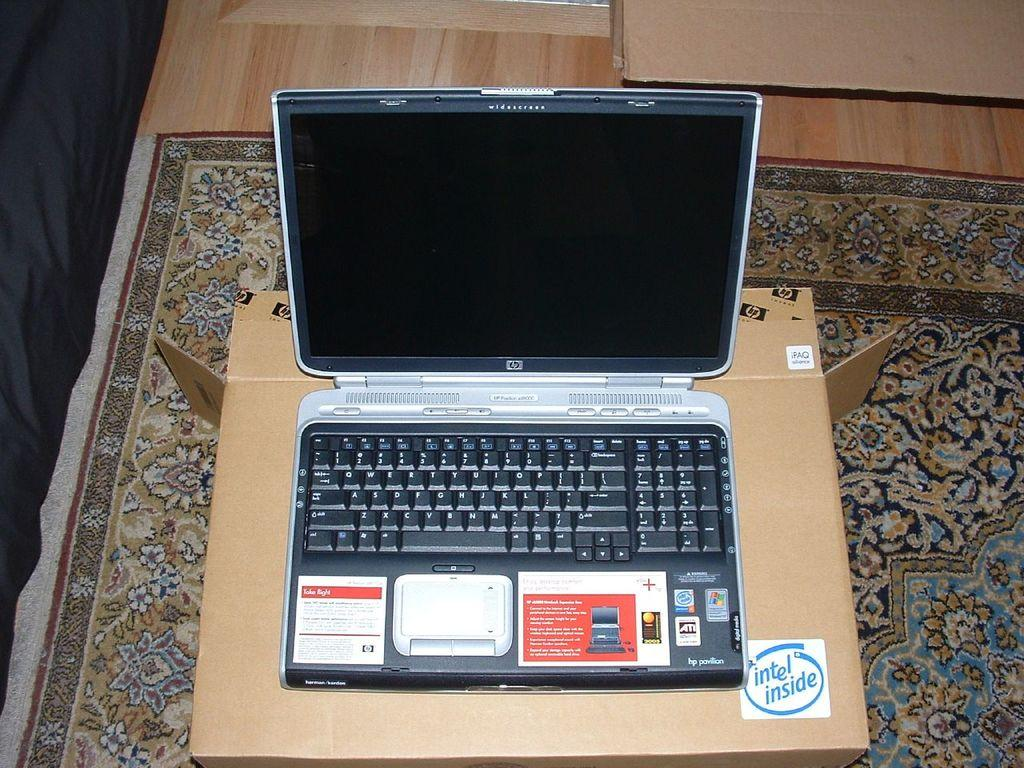<image>
Present a compact description of the photo's key features. A HP laptop is sitting on a cardboard box that has an intel inside sticker on it. 